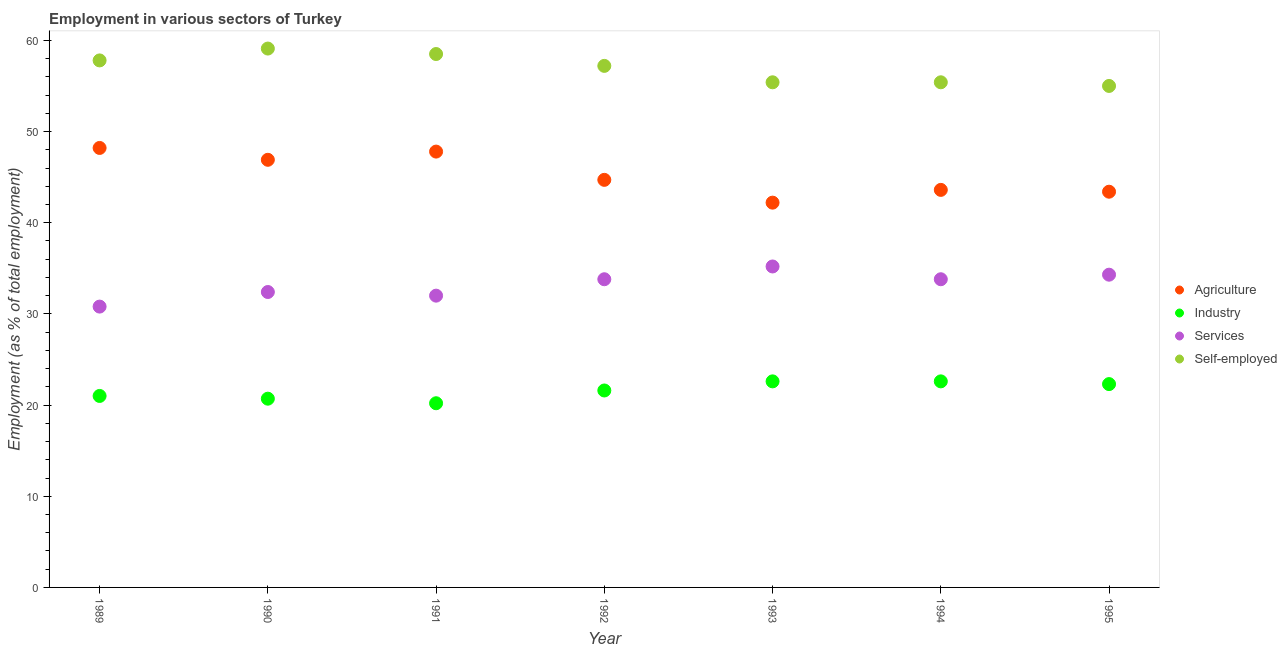What is the percentage of workers in agriculture in 1991?
Make the answer very short. 47.8. Across all years, what is the maximum percentage of self employed workers?
Your answer should be very brief. 59.1. Across all years, what is the minimum percentage of workers in industry?
Ensure brevity in your answer.  20.2. In which year was the percentage of workers in agriculture maximum?
Your answer should be compact. 1989. What is the total percentage of self employed workers in the graph?
Offer a terse response. 398.4. What is the difference between the percentage of workers in services in 1992 and that in 1993?
Ensure brevity in your answer.  -1.4. What is the difference between the percentage of workers in services in 1994 and the percentage of workers in industry in 1992?
Give a very brief answer. 12.2. What is the average percentage of workers in agriculture per year?
Offer a very short reply. 45.26. In the year 1991, what is the difference between the percentage of workers in agriculture and percentage of workers in services?
Your answer should be compact. 15.8. What is the ratio of the percentage of workers in industry in 1989 to that in 1991?
Offer a very short reply. 1.04. Is the percentage of workers in industry in 1993 less than that in 1995?
Provide a short and direct response. No. What is the difference between the highest and the second highest percentage of self employed workers?
Provide a short and direct response. 0.6. What is the difference between the highest and the lowest percentage of self employed workers?
Ensure brevity in your answer.  4.1. In how many years, is the percentage of workers in services greater than the average percentage of workers in services taken over all years?
Your answer should be compact. 4. Is the percentage of self employed workers strictly greater than the percentage of workers in agriculture over the years?
Make the answer very short. Yes. What is the difference between two consecutive major ticks on the Y-axis?
Give a very brief answer. 10. Are the values on the major ticks of Y-axis written in scientific E-notation?
Your response must be concise. No. Does the graph contain any zero values?
Offer a very short reply. No. What is the title of the graph?
Offer a very short reply. Employment in various sectors of Turkey. Does "United States" appear as one of the legend labels in the graph?
Ensure brevity in your answer.  No. What is the label or title of the X-axis?
Offer a terse response. Year. What is the label or title of the Y-axis?
Your answer should be compact. Employment (as % of total employment). What is the Employment (as % of total employment) of Agriculture in 1989?
Make the answer very short. 48.2. What is the Employment (as % of total employment) of Services in 1989?
Your answer should be very brief. 30.8. What is the Employment (as % of total employment) of Self-employed in 1989?
Make the answer very short. 57.8. What is the Employment (as % of total employment) of Agriculture in 1990?
Make the answer very short. 46.9. What is the Employment (as % of total employment) in Industry in 1990?
Make the answer very short. 20.7. What is the Employment (as % of total employment) of Services in 1990?
Your response must be concise. 32.4. What is the Employment (as % of total employment) of Self-employed in 1990?
Keep it short and to the point. 59.1. What is the Employment (as % of total employment) of Agriculture in 1991?
Ensure brevity in your answer.  47.8. What is the Employment (as % of total employment) in Industry in 1991?
Give a very brief answer. 20.2. What is the Employment (as % of total employment) of Services in 1991?
Offer a terse response. 32. What is the Employment (as % of total employment) of Self-employed in 1991?
Offer a very short reply. 58.5. What is the Employment (as % of total employment) of Agriculture in 1992?
Ensure brevity in your answer.  44.7. What is the Employment (as % of total employment) of Industry in 1992?
Your response must be concise. 21.6. What is the Employment (as % of total employment) in Services in 1992?
Your answer should be compact. 33.8. What is the Employment (as % of total employment) of Self-employed in 1992?
Provide a short and direct response. 57.2. What is the Employment (as % of total employment) of Agriculture in 1993?
Your response must be concise. 42.2. What is the Employment (as % of total employment) of Industry in 1993?
Offer a terse response. 22.6. What is the Employment (as % of total employment) of Services in 1993?
Ensure brevity in your answer.  35.2. What is the Employment (as % of total employment) of Self-employed in 1993?
Your answer should be compact. 55.4. What is the Employment (as % of total employment) of Agriculture in 1994?
Ensure brevity in your answer.  43.6. What is the Employment (as % of total employment) in Industry in 1994?
Provide a short and direct response. 22.6. What is the Employment (as % of total employment) in Services in 1994?
Offer a terse response. 33.8. What is the Employment (as % of total employment) in Self-employed in 1994?
Ensure brevity in your answer.  55.4. What is the Employment (as % of total employment) of Agriculture in 1995?
Your answer should be very brief. 43.4. What is the Employment (as % of total employment) of Industry in 1995?
Make the answer very short. 22.3. What is the Employment (as % of total employment) of Services in 1995?
Offer a terse response. 34.3. Across all years, what is the maximum Employment (as % of total employment) of Agriculture?
Provide a succinct answer. 48.2. Across all years, what is the maximum Employment (as % of total employment) of Industry?
Offer a terse response. 22.6. Across all years, what is the maximum Employment (as % of total employment) of Services?
Your response must be concise. 35.2. Across all years, what is the maximum Employment (as % of total employment) of Self-employed?
Your answer should be very brief. 59.1. Across all years, what is the minimum Employment (as % of total employment) in Agriculture?
Make the answer very short. 42.2. Across all years, what is the minimum Employment (as % of total employment) in Industry?
Give a very brief answer. 20.2. Across all years, what is the minimum Employment (as % of total employment) of Services?
Keep it short and to the point. 30.8. What is the total Employment (as % of total employment) in Agriculture in the graph?
Ensure brevity in your answer.  316.8. What is the total Employment (as % of total employment) in Industry in the graph?
Give a very brief answer. 151. What is the total Employment (as % of total employment) of Services in the graph?
Offer a terse response. 232.3. What is the total Employment (as % of total employment) in Self-employed in the graph?
Your answer should be compact. 398.4. What is the difference between the Employment (as % of total employment) of Industry in 1989 and that in 1990?
Provide a short and direct response. 0.3. What is the difference between the Employment (as % of total employment) in Services in 1989 and that in 1990?
Provide a short and direct response. -1.6. What is the difference between the Employment (as % of total employment) in Agriculture in 1989 and that in 1991?
Your answer should be very brief. 0.4. What is the difference between the Employment (as % of total employment) in Industry in 1989 and that in 1991?
Your answer should be compact. 0.8. What is the difference between the Employment (as % of total employment) of Agriculture in 1989 and that in 1992?
Your response must be concise. 3.5. What is the difference between the Employment (as % of total employment) of Agriculture in 1989 and that in 1994?
Ensure brevity in your answer.  4.6. What is the difference between the Employment (as % of total employment) of Industry in 1989 and that in 1994?
Offer a very short reply. -1.6. What is the difference between the Employment (as % of total employment) of Self-employed in 1989 and that in 1994?
Ensure brevity in your answer.  2.4. What is the difference between the Employment (as % of total employment) of Agriculture in 1989 and that in 1995?
Provide a short and direct response. 4.8. What is the difference between the Employment (as % of total employment) in Industry in 1989 and that in 1995?
Offer a very short reply. -1.3. What is the difference between the Employment (as % of total employment) in Services in 1989 and that in 1995?
Your answer should be compact. -3.5. What is the difference between the Employment (as % of total employment) in Self-employed in 1989 and that in 1995?
Offer a terse response. 2.8. What is the difference between the Employment (as % of total employment) in Industry in 1990 and that in 1991?
Offer a terse response. 0.5. What is the difference between the Employment (as % of total employment) of Services in 1990 and that in 1992?
Provide a succinct answer. -1.4. What is the difference between the Employment (as % of total employment) of Self-employed in 1990 and that in 1992?
Give a very brief answer. 1.9. What is the difference between the Employment (as % of total employment) of Industry in 1990 and that in 1993?
Keep it short and to the point. -1.9. What is the difference between the Employment (as % of total employment) of Self-employed in 1990 and that in 1993?
Your answer should be compact. 3.7. What is the difference between the Employment (as % of total employment) of Industry in 1990 and that in 1994?
Provide a succinct answer. -1.9. What is the difference between the Employment (as % of total employment) in Agriculture in 1990 and that in 1995?
Your answer should be very brief. 3.5. What is the difference between the Employment (as % of total employment) in Services in 1990 and that in 1995?
Give a very brief answer. -1.9. What is the difference between the Employment (as % of total employment) in Self-employed in 1990 and that in 1995?
Provide a succinct answer. 4.1. What is the difference between the Employment (as % of total employment) in Agriculture in 1991 and that in 1993?
Keep it short and to the point. 5.6. What is the difference between the Employment (as % of total employment) in Self-employed in 1991 and that in 1993?
Your response must be concise. 3.1. What is the difference between the Employment (as % of total employment) in Agriculture in 1991 and that in 1994?
Provide a succinct answer. 4.2. What is the difference between the Employment (as % of total employment) of Industry in 1991 and that in 1994?
Ensure brevity in your answer.  -2.4. What is the difference between the Employment (as % of total employment) in Services in 1991 and that in 1994?
Provide a succinct answer. -1.8. What is the difference between the Employment (as % of total employment) of Self-employed in 1991 and that in 1994?
Provide a short and direct response. 3.1. What is the difference between the Employment (as % of total employment) in Industry in 1991 and that in 1995?
Provide a short and direct response. -2.1. What is the difference between the Employment (as % of total employment) in Self-employed in 1991 and that in 1995?
Your response must be concise. 3.5. What is the difference between the Employment (as % of total employment) of Agriculture in 1992 and that in 1993?
Provide a succinct answer. 2.5. What is the difference between the Employment (as % of total employment) of Industry in 1992 and that in 1993?
Offer a very short reply. -1. What is the difference between the Employment (as % of total employment) of Services in 1992 and that in 1993?
Provide a short and direct response. -1.4. What is the difference between the Employment (as % of total employment) of Agriculture in 1992 and that in 1994?
Keep it short and to the point. 1.1. What is the difference between the Employment (as % of total employment) of Industry in 1992 and that in 1994?
Your answer should be compact. -1. What is the difference between the Employment (as % of total employment) in Services in 1992 and that in 1994?
Provide a short and direct response. 0. What is the difference between the Employment (as % of total employment) in Self-employed in 1992 and that in 1994?
Your answer should be very brief. 1.8. What is the difference between the Employment (as % of total employment) of Services in 1992 and that in 1995?
Provide a short and direct response. -0.5. What is the difference between the Employment (as % of total employment) of Industry in 1993 and that in 1994?
Your answer should be very brief. 0. What is the difference between the Employment (as % of total employment) in Self-employed in 1993 and that in 1994?
Ensure brevity in your answer.  0. What is the difference between the Employment (as % of total employment) in Services in 1993 and that in 1995?
Your response must be concise. 0.9. What is the difference between the Employment (as % of total employment) in Self-employed in 1993 and that in 1995?
Keep it short and to the point. 0.4. What is the difference between the Employment (as % of total employment) of Agriculture in 1994 and that in 1995?
Give a very brief answer. 0.2. What is the difference between the Employment (as % of total employment) in Industry in 1994 and that in 1995?
Give a very brief answer. 0.3. What is the difference between the Employment (as % of total employment) of Industry in 1989 and the Employment (as % of total employment) of Services in 1990?
Offer a terse response. -11.4. What is the difference between the Employment (as % of total employment) in Industry in 1989 and the Employment (as % of total employment) in Self-employed in 1990?
Provide a succinct answer. -38.1. What is the difference between the Employment (as % of total employment) in Services in 1989 and the Employment (as % of total employment) in Self-employed in 1990?
Ensure brevity in your answer.  -28.3. What is the difference between the Employment (as % of total employment) of Agriculture in 1989 and the Employment (as % of total employment) of Self-employed in 1991?
Keep it short and to the point. -10.3. What is the difference between the Employment (as % of total employment) in Industry in 1989 and the Employment (as % of total employment) in Services in 1991?
Provide a short and direct response. -11. What is the difference between the Employment (as % of total employment) in Industry in 1989 and the Employment (as % of total employment) in Self-employed in 1991?
Make the answer very short. -37.5. What is the difference between the Employment (as % of total employment) of Services in 1989 and the Employment (as % of total employment) of Self-employed in 1991?
Make the answer very short. -27.7. What is the difference between the Employment (as % of total employment) of Agriculture in 1989 and the Employment (as % of total employment) of Industry in 1992?
Make the answer very short. 26.6. What is the difference between the Employment (as % of total employment) in Agriculture in 1989 and the Employment (as % of total employment) in Services in 1992?
Your answer should be compact. 14.4. What is the difference between the Employment (as % of total employment) in Agriculture in 1989 and the Employment (as % of total employment) in Self-employed in 1992?
Give a very brief answer. -9. What is the difference between the Employment (as % of total employment) of Industry in 1989 and the Employment (as % of total employment) of Self-employed in 1992?
Your answer should be compact. -36.2. What is the difference between the Employment (as % of total employment) of Services in 1989 and the Employment (as % of total employment) of Self-employed in 1992?
Provide a short and direct response. -26.4. What is the difference between the Employment (as % of total employment) in Agriculture in 1989 and the Employment (as % of total employment) in Industry in 1993?
Provide a succinct answer. 25.6. What is the difference between the Employment (as % of total employment) in Agriculture in 1989 and the Employment (as % of total employment) in Services in 1993?
Your response must be concise. 13. What is the difference between the Employment (as % of total employment) of Industry in 1989 and the Employment (as % of total employment) of Self-employed in 1993?
Provide a succinct answer. -34.4. What is the difference between the Employment (as % of total employment) in Services in 1989 and the Employment (as % of total employment) in Self-employed in 1993?
Keep it short and to the point. -24.6. What is the difference between the Employment (as % of total employment) in Agriculture in 1989 and the Employment (as % of total employment) in Industry in 1994?
Offer a very short reply. 25.6. What is the difference between the Employment (as % of total employment) of Agriculture in 1989 and the Employment (as % of total employment) of Self-employed in 1994?
Your response must be concise. -7.2. What is the difference between the Employment (as % of total employment) in Industry in 1989 and the Employment (as % of total employment) in Self-employed in 1994?
Give a very brief answer. -34.4. What is the difference between the Employment (as % of total employment) of Services in 1989 and the Employment (as % of total employment) of Self-employed in 1994?
Provide a succinct answer. -24.6. What is the difference between the Employment (as % of total employment) of Agriculture in 1989 and the Employment (as % of total employment) of Industry in 1995?
Provide a succinct answer. 25.9. What is the difference between the Employment (as % of total employment) of Industry in 1989 and the Employment (as % of total employment) of Self-employed in 1995?
Keep it short and to the point. -34. What is the difference between the Employment (as % of total employment) of Services in 1989 and the Employment (as % of total employment) of Self-employed in 1995?
Your response must be concise. -24.2. What is the difference between the Employment (as % of total employment) in Agriculture in 1990 and the Employment (as % of total employment) in Industry in 1991?
Offer a terse response. 26.7. What is the difference between the Employment (as % of total employment) in Agriculture in 1990 and the Employment (as % of total employment) in Services in 1991?
Make the answer very short. 14.9. What is the difference between the Employment (as % of total employment) of Industry in 1990 and the Employment (as % of total employment) of Self-employed in 1991?
Make the answer very short. -37.8. What is the difference between the Employment (as % of total employment) in Services in 1990 and the Employment (as % of total employment) in Self-employed in 1991?
Give a very brief answer. -26.1. What is the difference between the Employment (as % of total employment) in Agriculture in 1990 and the Employment (as % of total employment) in Industry in 1992?
Give a very brief answer. 25.3. What is the difference between the Employment (as % of total employment) of Agriculture in 1990 and the Employment (as % of total employment) of Services in 1992?
Ensure brevity in your answer.  13.1. What is the difference between the Employment (as % of total employment) of Agriculture in 1990 and the Employment (as % of total employment) of Self-employed in 1992?
Your answer should be very brief. -10.3. What is the difference between the Employment (as % of total employment) in Industry in 1990 and the Employment (as % of total employment) in Self-employed in 1992?
Provide a succinct answer. -36.5. What is the difference between the Employment (as % of total employment) of Services in 1990 and the Employment (as % of total employment) of Self-employed in 1992?
Give a very brief answer. -24.8. What is the difference between the Employment (as % of total employment) of Agriculture in 1990 and the Employment (as % of total employment) of Industry in 1993?
Offer a terse response. 24.3. What is the difference between the Employment (as % of total employment) in Agriculture in 1990 and the Employment (as % of total employment) in Services in 1993?
Your answer should be compact. 11.7. What is the difference between the Employment (as % of total employment) of Industry in 1990 and the Employment (as % of total employment) of Self-employed in 1993?
Give a very brief answer. -34.7. What is the difference between the Employment (as % of total employment) in Services in 1990 and the Employment (as % of total employment) in Self-employed in 1993?
Offer a terse response. -23. What is the difference between the Employment (as % of total employment) of Agriculture in 1990 and the Employment (as % of total employment) of Industry in 1994?
Provide a short and direct response. 24.3. What is the difference between the Employment (as % of total employment) in Agriculture in 1990 and the Employment (as % of total employment) in Services in 1994?
Offer a terse response. 13.1. What is the difference between the Employment (as % of total employment) of Industry in 1990 and the Employment (as % of total employment) of Services in 1994?
Keep it short and to the point. -13.1. What is the difference between the Employment (as % of total employment) in Industry in 1990 and the Employment (as % of total employment) in Self-employed in 1994?
Offer a terse response. -34.7. What is the difference between the Employment (as % of total employment) in Services in 1990 and the Employment (as % of total employment) in Self-employed in 1994?
Provide a short and direct response. -23. What is the difference between the Employment (as % of total employment) of Agriculture in 1990 and the Employment (as % of total employment) of Industry in 1995?
Offer a very short reply. 24.6. What is the difference between the Employment (as % of total employment) of Agriculture in 1990 and the Employment (as % of total employment) of Self-employed in 1995?
Make the answer very short. -8.1. What is the difference between the Employment (as % of total employment) of Industry in 1990 and the Employment (as % of total employment) of Services in 1995?
Make the answer very short. -13.6. What is the difference between the Employment (as % of total employment) of Industry in 1990 and the Employment (as % of total employment) of Self-employed in 1995?
Give a very brief answer. -34.3. What is the difference between the Employment (as % of total employment) of Services in 1990 and the Employment (as % of total employment) of Self-employed in 1995?
Make the answer very short. -22.6. What is the difference between the Employment (as % of total employment) of Agriculture in 1991 and the Employment (as % of total employment) of Industry in 1992?
Offer a terse response. 26.2. What is the difference between the Employment (as % of total employment) of Agriculture in 1991 and the Employment (as % of total employment) of Services in 1992?
Provide a short and direct response. 14. What is the difference between the Employment (as % of total employment) in Industry in 1991 and the Employment (as % of total employment) in Self-employed in 1992?
Your answer should be compact. -37. What is the difference between the Employment (as % of total employment) of Services in 1991 and the Employment (as % of total employment) of Self-employed in 1992?
Provide a short and direct response. -25.2. What is the difference between the Employment (as % of total employment) in Agriculture in 1991 and the Employment (as % of total employment) in Industry in 1993?
Provide a short and direct response. 25.2. What is the difference between the Employment (as % of total employment) in Agriculture in 1991 and the Employment (as % of total employment) in Services in 1993?
Provide a succinct answer. 12.6. What is the difference between the Employment (as % of total employment) of Industry in 1991 and the Employment (as % of total employment) of Self-employed in 1993?
Your answer should be compact. -35.2. What is the difference between the Employment (as % of total employment) of Services in 1991 and the Employment (as % of total employment) of Self-employed in 1993?
Offer a terse response. -23.4. What is the difference between the Employment (as % of total employment) in Agriculture in 1991 and the Employment (as % of total employment) in Industry in 1994?
Make the answer very short. 25.2. What is the difference between the Employment (as % of total employment) in Industry in 1991 and the Employment (as % of total employment) in Self-employed in 1994?
Offer a terse response. -35.2. What is the difference between the Employment (as % of total employment) in Services in 1991 and the Employment (as % of total employment) in Self-employed in 1994?
Offer a very short reply. -23.4. What is the difference between the Employment (as % of total employment) in Agriculture in 1991 and the Employment (as % of total employment) in Industry in 1995?
Your response must be concise. 25.5. What is the difference between the Employment (as % of total employment) in Agriculture in 1991 and the Employment (as % of total employment) in Services in 1995?
Give a very brief answer. 13.5. What is the difference between the Employment (as % of total employment) in Industry in 1991 and the Employment (as % of total employment) in Services in 1995?
Provide a short and direct response. -14.1. What is the difference between the Employment (as % of total employment) of Industry in 1991 and the Employment (as % of total employment) of Self-employed in 1995?
Provide a short and direct response. -34.8. What is the difference between the Employment (as % of total employment) of Agriculture in 1992 and the Employment (as % of total employment) of Industry in 1993?
Make the answer very short. 22.1. What is the difference between the Employment (as % of total employment) in Agriculture in 1992 and the Employment (as % of total employment) in Services in 1993?
Keep it short and to the point. 9.5. What is the difference between the Employment (as % of total employment) of Agriculture in 1992 and the Employment (as % of total employment) of Self-employed in 1993?
Keep it short and to the point. -10.7. What is the difference between the Employment (as % of total employment) of Industry in 1992 and the Employment (as % of total employment) of Self-employed in 1993?
Your answer should be very brief. -33.8. What is the difference between the Employment (as % of total employment) of Services in 1992 and the Employment (as % of total employment) of Self-employed in 1993?
Offer a terse response. -21.6. What is the difference between the Employment (as % of total employment) of Agriculture in 1992 and the Employment (as % of total employment) of Industry in 1994?
Give a very brief answer. 22.1. What is the difference between the Employment (as % of total employment) of Agriculture in 1992 and the Employment (as % of total employment) of Services in 1994?
Provide a succinct answer. 10.9. What is the difference between the Employment (as % of total employment) in Industry in 1992 and the Employment (as % of total employment) in Services in 1994?
Your answer should be very brief. -12.2. What is the difference between the Employment (as % of total employment) of Industry in 1992 and the Employment (as % of total employment) of Self-employed in 1994?
Your response must be concise. -33.8. What is the difference between the Employment (as % of total employment) of Services in 1992 and the Employment (as % of total employment) of Self-employed in 1994?
Your answer should be compact. -21.6. What is the difference between the Employment (as % of total employment) in Agriculture in 1992 and the Employment (as % of total employment) in Industry in 1995?
Make the answer very short. 22.4. What is the difference between the Employment (as % of total employment) of Agriculture in 1992 and the Employment (as % of total employment) of Self-employed in 1995?
Provide a succinct answer. -10.3. What is the difference between the Employment (as % of total employment) in Industry in 1992 and the Employment (as % of total employment) in Self-employed in 1995?
Provide a succinct answer. -33.4. What is the difference between the Employment (as % of total employment) in Services in 1992 and the Employment (as % of total employment) in Self-employed in 1995?
Give a very brief answer. -21.2. What is the difference between the Employment (as % of total employment) in Agriculture in 1993 and the Employment (as % of total employment) in Industry in 1994?
Give a very brief answer. 19.6. What is the difference between the Employment (as % of total employment) of Agriculture in 1993 and the Employment (as % of total employment) of Services in 1994?
Your answer should be very brief. 8.4. What is the difference between the Employment (as % of total employment) of Agriculture in 1993 and the Employment (as % of total employment) of Self-employed in 1994?
Make the answer very short. -13.2. What is the difference between the Employment (as % of total employment) of Industry in 1993 and the Employment (as % of total employment) of Services in 1994?
Keep it short and to the point. -11.2. What is the difference between the Employment (as % of total employment) of Industry in 1993 and the Employment (as % of total employment) of Self-employed in 1994?
Ensure brevity in your answer.  -32.8. What is the difference between the Employment (as % of total employment) in Services in 1993 and the Employment (as % of total employment) in Self-employed in 1994?
Provide a succinct answer. -20.2. What is the difference between the Employment (as % of total employment) in Industry in 1993 and the Employment (as % of total employment) in Self-employed in 1995?
Offer a very short reply. -32.4. What is the difference between the Employment (as % of total employment) in Services in 1993 and the Employment (as % of total employment) in Self-employed in 1995?
Your answer should be very brief. -19.8. What is the difference between the Employment (as % of total employment) in Agriculture in 1994 and the Employment (as % of total employment) in Industry in 1995?
Offer a terse response. 21.3. What is the difference between the Employment (as % of total employment) in Industry in 1994 and the Employment (as % of total employment) in Self-employed in 1995?
Your answer should be compact. -32.4. What is the difference between the Employment (as % of total employment) in Services in 1994 and the Employment (as % of total employment) in Self-employed in 1995?
Your answer should be compact. -21.2. What is the average Employment (as % of total employment) in Agriculture per year?
Ensure brevity in your answer.  45.26. What is the average Employment (as % of total employment) in Industry per year?
Keep it short and to the point. 21.57. What is the average Employment (as % of total employment) in Services per year?
Give a very brief answer. 33.19. What is the average Employment (as % of total employment) of Self-employed per year?
Make the answer very short. 56.91. In the year 1989, what is the difference between the Employment (as % of total employment) in Agriculture and Employment (as % of total employment) in Industry?
Your answer should be very brief. 27.2. In the year 1989, what is the difference between the Employment (as % of total employment) in Agriculture and Employment (as % of total employment) in Self-employed?
Provide a succinct answer. -9.6. In the year 1989, what is the difference between the Employment (as % of total employment) of Industry and Employment (as % of total employment) of Services?
Your answer should be compact. -9.8. In the year 1989, what is the difference between the Employment (as % of total employment) of Industry and Employment (as % of total employment) of Self-employed?
Your answer should be very brief. -36.8. In the year 1989, what is the difference between the Employment (as % of total employment) in Services and Employment (as % of total employment) in Self-employed?
Offer a terse response. -27. In the year 1990, what is the difference between the Employment (as % of total employment) of Agriculture and Employment (as % of total employment) of Industry?
Give a very brief answer. 26.2. In the year 1990, what is the difference between the Employment (as % of total employment) of Agriculture and Employment (as % of total employment) of Self-employed?
Give a very brief answer. -12.2. In the year 1990, what is the difference between the Employment (as % of total employment) of Industry and Employment (as % of total employment) of Services?
Offer a terse response. -11.7. In the year 1990, what is the difference between the Employment (as % of total employment) of Industry and Employment (as % of total employment) of Self-employed?
Provide a succinct answer. -38.4. In the year 1990, what is the difference between the Employment (as % of total employment) in Services and Employment (as % of total employment) in Self-employed?
Provide a short and direct response. -26.7. In the year 1991, what is the difference between the Employment (as % of total employment) in Agriculture and Employment (as % of total employment) in Industry?
Offer a terse response. 27.6. In the year 1991, what is the difference between the Employment (as % of total employment) in Agriculture and Employment (as % of total employment) in Services?
Offer a terse response. 15.8. In the year 1991, what is the difference between the Employment (as % of total employment) of Industry and Employment (as % of total employment) of Services?
Keep it short and to the point. -11.8. In the year 1991, what is the difference between the Employment (as % of total employment) of Industry and Employment (as % of total employment) of Self-employed?
Your answer should be very brief. -38.3. In the year 1991, what is the difference between the Employment (as % of total employment) of Services and Employment (as % of total employment) of Self-employed?
Your response must be concise. -26.5. In the year 1992, what is the difference between the Employment (as % of total employment) in Agriculture and Employment (as % of total employment) in Industry?
Keep it short and to the point. 23.1. In the year 1992, what is the difference between the Employment (as % of total employment) in Agriculture and Employment (as % of total employment) in Self-employed?
Your answer should be compact. -12.5. In the year 1992, what is the difference between the Employment (as % of total employment) of Industry and Employment (as % of total employment) of Services?
Your answer should be very brief. -12.2. In the year 1992, what is the difference between the Employment (as % of total employment) in Industry and Employment (as % of total employment) in Self-employed?
Your answer should be very brief. -35.6. In the year 1992, what is the difference between the Employment (as % of total employment) of Services and Employment (as % of total employment) of Self-employed?
Offer a very short reply. -23.4. In the year 1993, what is the difference between the Employment (as % of total employment) in Agriculture and Employment (as % of total employment) in Industry?
Offer a terse response. 19.6. In the year 1993, what is the difference between the Employment (as % of total employment) of Agriculture and Employment (as % of total employment) of Services?
Ensure brevity in your answer.  7. In the year 1993, what is the difference between the Employment (as % of total employment) in Agriculture and Employment (as % of total employment) in Self-employed?
Your answer should be very brief. -13.2. In the year 1993, what is the difference between the Employment (as % of total employment) in Industry and Employment (as % of total employment) in Self-employed?
Ensure brevity in your answer.  -32.8. In the year 1993, what is the difference between the Employment (as % of total employment) of Services and Employment (as % of total employment) of Self-employed?
Offer a terse response. -20.2. In the year 1994, what is the difference between the Employment (as % of total employment) of Industry and Employment (as % of total employment) of Services?
Ensure brevity in your answer.  -11.2. In the year 1994, what is the difference between the Employment (as % of total employment) of Industry and Employment (as % of total employment) of Self-employed?
Offer a terse response. -32.8. In the year 1994, what is the difference between the Employment (as % of total employment) in Services and Employment (as % of total employment) in Self-employed?
Provide a short and direct response. -21.6. In the year 1995, what is the difference between the Employment (as % of total employment) in Agriculture and Employment (as % of total employment) in Industry?
Give a very brief answer. 21.1. In the year 1995, what is the difference between the Employment (as % of total employment) in Agriculture and Employment (as % of total employment) in Self-employed?
Your response must be concise. -11.6. In the year 1995, what is the difference between the Employment (as % of total employment) of Industry and Employment (as % of total employment) of Services?
Give a very brief answer. -12. In the year 1995, what is the difference between the Employment (as % of total employment) in Industry and Employment (as % of total employment) in Self-employed?
Offer a very short reply. -32.7. In the year 1995, what is the difference between the Employment (as % of total employment) in Services and Employment (as % of total employment) in Self-employed?
Give a very brief answer. -20.7. What is the ratio of the Employment (as % of total employment) in Agriculture in 1989 to that in 1990?
Provide a succinct answer. 1.03. What is the ratio of the Employment (as % of total employment) in Industry in 1989 to that in 1990?
Ensure brevity in your answer.  1.01. What is the ratio of the Employment (as % of total employment) of Services in 1989 to that in 1990?
Provide a succinct answer. 0.95. What is the ratio of the Employment (as % of total employment) of Agriculture in 1989 to that in 1991?
Give a very brief answer. 1.01. What is the ratio of the Employment (as % of total employment) of Industry in 1989 to that in 1991?
Provide a succinct answer. 1.04. What is the ratio of the Employment (as % of total employment) in Services in 1989 to that in 1991?
Provide a succinct answer. 0.96. What is the ratio of the Employment (as % of total employment) in Self-employed in 1989 to that in 1991?
Your response must be concise. 0.99. What is the ratio of the Employment (as % of total employment) of Agriculture in 1989 to that in 1992?
Ensure brevity in your answer.  1.08. What is the ratio of the Employment (as % of total employment) of Industry in 1989 to that in 1992?
Keep it short and to the point. 0.97. What is the ratio of the Employment (as % of total employment) in Services in 1989 to that in 1992?
Provide a succinct answer. 0.91. What is the ratio of the Employment (as % of total employment) of Self-employed in 1989 to that in 1992?
Your answer should be very brief. 1.01. What is the ratio of the Employment (as % of total employment) in Agriculture in 1989 to that in 1993?
Your answer should be compact. 1.14. What is the ratio of the Employment (as % of total employment) of Industry in 1989 to that in 1993?
Keep it short and to the point. 0.93. What is the ratio of the Employment (as % of total employment) of Services in 1989 to that in 1993?
Offer a very short reply. 0.88. What is the ratio of the Employment (as % of total employment) in Self-employed in 1989 to that in 1993?
Your answer should be very brief. 1.04. What is the ratio of the Employment (as % of total employment) in Agriculture in 1989 to that in 1994?
Your answer should be compact. 1.11. What is the ratio of the Employment (as % of total employment) of Industry in 1989 to that in 1994?
Make the answer very short. 0.93. What is the ratio of the Employment (as % of total employment) in Services in 1989 to that in 1994?
Your response must be concise. 0.91. What is the ratio of the Employment (as % of total employment) of Self-employed in 1989 to that in 1994?
Your answer should be very brief. 1.04. What is the ratio of the Employment (as % of total employment) of Agriculture in 1989 to that in 1995?
Make the answer very short. 1.11. What is the ratio of the Employment (as % of total employment) in Industry in 1989 to that in 1995?
Ensure brevity in your answer.  0.94. What is the ratio of the Employment (as % of total employment) in Services in 1989 to that in 1995?
Provide a short and direct response. 0.9. What is the ratio of the Employment (as % of total employment) of Self-employed in 1989 to that in 1995?
Give a very brief answer. 1.05. What is the ratio of the Employment (as % of total employment) of Agriculture in 1990 to that in 1991?
Provide a succinct answer. 0.98. What is the ratio of the Employment (as % of total employment) in Industry in 1990 to that in 1991?
Your answer should be very brief. 1.02. What is the ratio of the Employment (as % of total employment) in Services in 1990 to that in 1991?
Offer a terse response. 1.01. What is the ratio of the Employment (as % of total employment) of Self-employed in 1990 to that in 1991?
Your response must be concise. 1.01. What is the ratio of the Employment (as % of total employment) in Agriculture in 1990 to that in 1992?
Provide a succinct answer. 1.05. What is the ratio of the Employment (as % of total employment) in Industry in 1990 to that in 1992?
Make the answer very short. 0.96. What is the ratio of the Employment (as % of total employment) of Services in 1990 to that in 1992?
Give a very brief answer. 0.96. What is the ratio of the Employment (as % of total employment) in Self-employed in 1990 to that in 1992?
Make the answer very short. 1.03. What is the ratio of the Employment (as % of total employment) of Agriculture in 1990 to that in 1993?
Your response must be concise. 1.11. What is the ratio of the Employment (as % of total employment) in Industry in 1990 to that in 1993?
Provide a succinct answer. 0.92. What is the ratio of the Employment (as % of total employment) in Services in 1990 to that in 1993?
Your response must be concise. 0.92. What is the ratio of the Employment (as % of total employment) in Self-employed in 1990 to that in 1993?
Offer a very short reply. 1.07. What is the ratio of the Employment (as % of total employment) of Agriculture in 1990 to that in 1994?
Give a very brief answer. 1.08. What is the ratio of the Employment (as % of total employment) in Industry in 1990 to that in 1994?
Ensure brevity in your answer.  0.92. What is the ratio of the Employment (as % of total employment) of Services in 1990 to that in 1994?
Make the answer very short. 0.96. What is the ratio of the Employment (as % of total employment) in Self-employed in 1990 to that in 1994?
Your response must be concise. 1.07. What is the ratio of the Employment (as % of total employment) of Agriculture in 1990 to that in 1995?
Ensure brevity in your answer.  1.08. What is the ratio of the Employment (as % of total employment) in Industry in 1990 to that in 1995?
Your answer should be compact. 0.93. What is the ratio of the Employment (as % of total employment) in Services in 1990 to that in 1995?
Offer a very short reply. 0.94. What is the ratio of the Employment (as % of total employment) of Self-employed in 1990 to that in 1995?
Offer a terse response. 1.07. What is the ratio of the Employment (as % of total employment) of Agriculture in 1991 to that in 1992?
Give a very brief answer. 1.07. What is the ratio of the Employment (as % of total employment) in Industry in 1991 to that in 1992?
Ensure brevity in your answer.  0.94. What is the ratio of the Employment (as % of total employment) in Services in 1991 to that in 1992?
Provide a short and direct response. 0.95. What is the ratio of the Employment (as % of total employment) of Self-employed in 1991 to that in 1992?
Provide a short and direct response. 1.02. What is the ratio of the Employment (as % of total employment) in Agriculture in 1991 to that in 1993?
Provide a succinct answer. 1.13. What is the ratio of the Employment (as % of total employment) of Industry in 1991 to that in 1993?
Provide a short and direct response. 0.89. What is the ratio of the Employment (as % of total employment) in Services in 1991 to that in 1993?
Make the answer very short. 0.91. What is the ratio of the Employment (as % of total employment) of Self-employed in 1991 to that in 1993?
Your answer should be very brief. 1.06. What is the ratio of the Employment (as % of total employment) in Agriculture in 1991 to that in 1994?
Your answer should be compact. 1.1. What is the ratio of the Employment (as % of total employment) in Industry in 1991 to that in 1994?
Your answer should be very brief. 0.89. What is the ratio of the Employment (as % of total employment) in Services in 1991 to that in 1994?
Provide a succinct answer. 0.95. What is the ratio of the Employment (as % of total employment) of Self-employed in 1991 to that in 1994?
Give a very brief answer. 1.06. What is the ratio of the Employment (as % of total employment) in Agriculture in 1991 to that in 1995?
Give a very brief answer. 1.1. What is the ratio of the Employment (as % of total employment) in Industry in 1991 to that in 1995?
Make the answer very short. 0.91. What is the ratio of the Employment (as % of total employment) of Services in 1991 to that in 1995?
Your answer should be very brief. 0.93. What is the ratio of the Employment (as % of total employment) of Self-employed in 1991 to that in 1995?
Offer a very short reply. 1.06. What is the ratio of the Employment (as % of total employment) in Agriculture in 1992 to that in 1993?
Your answer should be compact. 1.06. What is the ratio of the Employment (as % of total employment) of Industry in 1992 to that in 1993?
Provide a short and direct response. 0.96. What is the ratio of the Employment (as % of total employment) of Services in 1992 to that in 1993?
Your response must be concise. 0.96. What is the ratio of the Employment (as % of total employment) of Self-employed in 1992 to that in 1993?
Your answer should be compact. 1.03. What is the ratio of the Employment (as % of total employment) of Agriculture in 1992 to that in 1994?
Your answer should be very brief. 1.03. What is the ratio of the Employment (as % of total employment) in Industry in 1992 to that in 1994?
Ensure brevity in your answer.  0.96. What is the ratio of the Employment (as % of total employment) of Self-employed in 1992 to that in 1994?
Provide a succinct answer. 1.03. What is the ratio of the Employment (as % of total employment) in Agriculture in 1992 to that in 1995?
Give a very brief answer. 1.03. What is the ratio of the Employment (as % of total employment) of Industry in 1992 to that in 1995?
Your answer should be very brief. 0.97. What is the ratio of the Employment (as % of total employment) in Services in 1992 to that in 1995?
Keep it short and to the point. 0.99. What is the ratio of the Employment (as % of total employment) in Agriculture in 1993 to that in 1994?
Offer a very short reply. 0.97. What is the ratio of the Employment (as % of total employment) of Services in 1993 to that in 1994?
Your answer should be very brief. 1.04. What is the ratio of the Employment (as % of total employment) of Agriculture in 1993 to that in 1995?
Keep it short and to the point. 0.97. What is the ratio of the Employment (as % of total employment) in Industry in 1993 to that in 1995?
Make the answer very short. 1.01. What is the ratio of the Employment (as % of total employment) of Services in 1993 to that in 1995?
Provide a succinct answer. 1.03. What is the ratio of the Employment (as % of total employment) of Self-employed in 1993 to that in 1995?
Provide a short and direct response. 1.01. What is the ratio of the Employment (as % of total employment) of Industry in 1994 to that in 1995?
Make the answer very short. 1.01. What is the ratio of the Employment (as % of total employment) of Services in 1994 to that in 1995?
Provide a short and direct response. 0.99. What is the ratio of the Employment (as % of total employment) of Self-employed in 1994 to that in 1995?
Your response must be concise. 1.01. What is the difference between the highest and the second highest Employment (as % of total employment) in Services?
Ensure brevity in your answer.  0.9. What is the difference between the highest and the lowest Employment (as % of total employment) of Agriculture?
Offer a very short reply. 6. What is the difference between the highest and the lowest Employment (as % of total employment) in Industry?
Provide a short and direct response. 2.4. What is the difference between the highest and the lowest Employment (as % of total employment) in Self-employed?
Offer a very short reply. 4.1. 